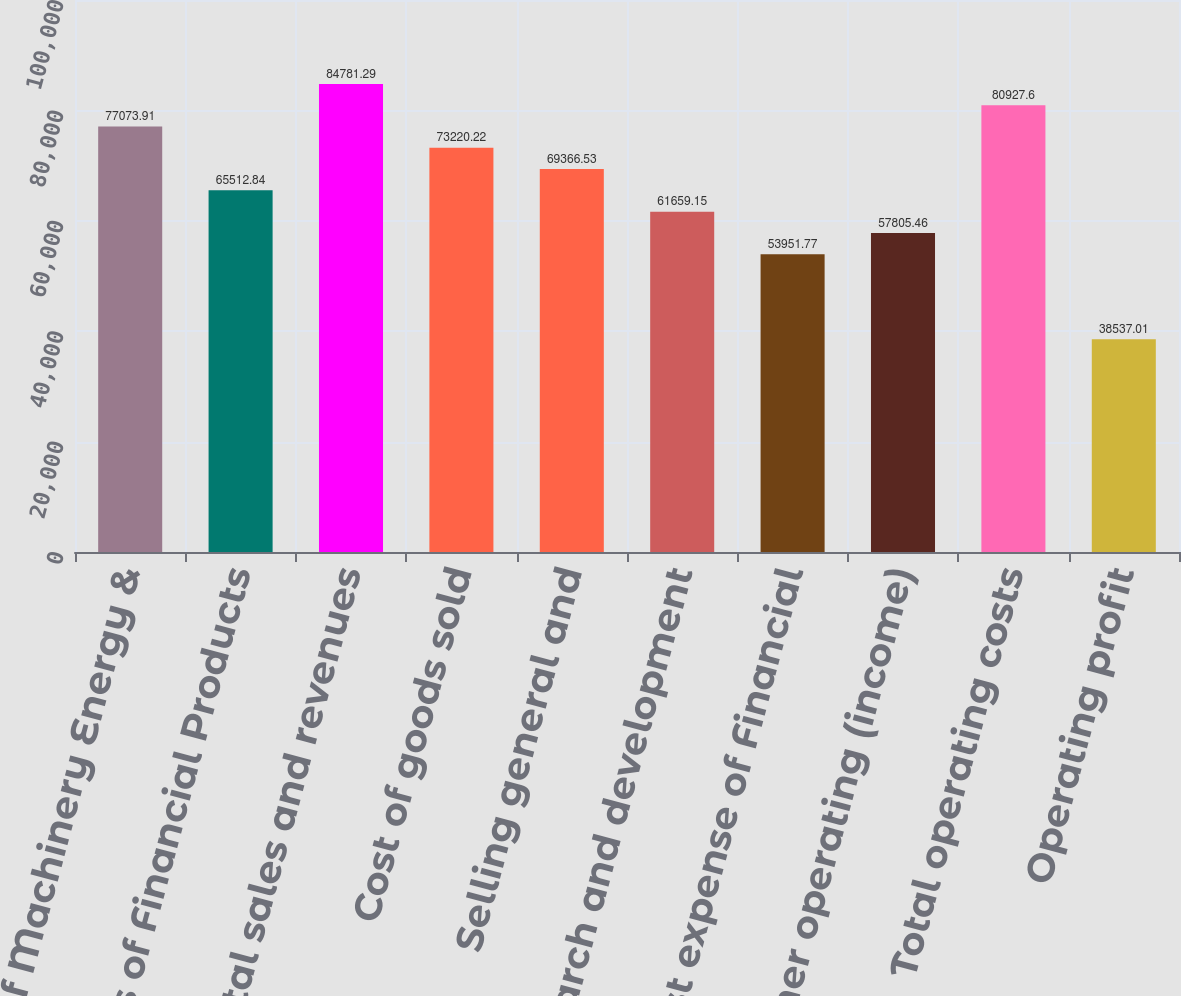Convert chart to OTSL. <chart><loc_0><loc_0><loc_500><loc_500><bar_chart><fcel>Sales of Machinery Energy &<fcel>Revenues of Financial Products<fcel>Total sales and revenues<fcel>Cost of goods sold<fcel>Selling general and<fcel>Research and development<fcel>Interest expense of Financial<fcel>Other operating (income)<fcel>Total operating costs<fcel>Operating profit<nl><fcel>77073.9<fcel>65512.8<fcel>84781.3<fcel>73220.2<fcel>69366.5<fcel>61659.2<fcel>53951.8<fcel>57805.5<fcel>80927.6<fcel>38537<nl></chart> 